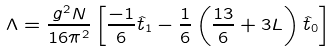<formula> <loc_0><loc_0><loc_500><loc_500>\Lambda = \frac { g ^ { 2 } N } { 1 6 \pi ^ { 2 } } \left [ \frac { - 1 } { 6 } \hat { t } _ { 1 } - \frac { 1 } { 6 } \left ( \frac { 1 3 } { 6 } + 3 L \right ) \hat { t } _ { 0 } \right ]</formula> 